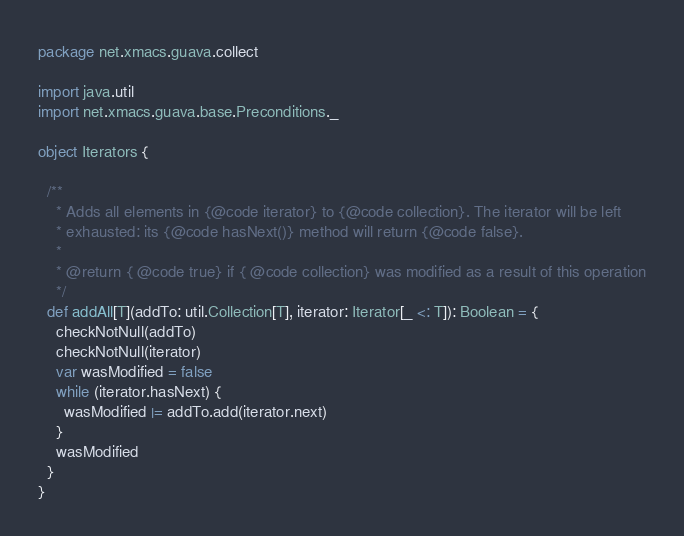Convert code to text. <code><loc_0><loc_0><loc_500><loc_500><_Scala_>package net.xmacs.guava.collect

import java.util
import net.xmacs.guava.base.Preconditions._

object Iterators {

  /**
    * Adds all elements in {@code iterator} to {@code collection}. The iterator will be left
    * exhausted: its {@code hasNext()} method will return {@code false}.
    *
    * @return { @code true} if { @code collection} was modified as a result of this operation
    */
  def addAll[T](addTo: util.Collection[T], iterator: Iterator[_ <: T]): Boolean = {
    checkNotNull(addTo)
    checkNotNull(iterator)
    var wasModified = false
    while (iterator.hasNext) {
      wasModified |= addTo.add(iterator.next)
    }
    wasModified
  }
}
</code> 